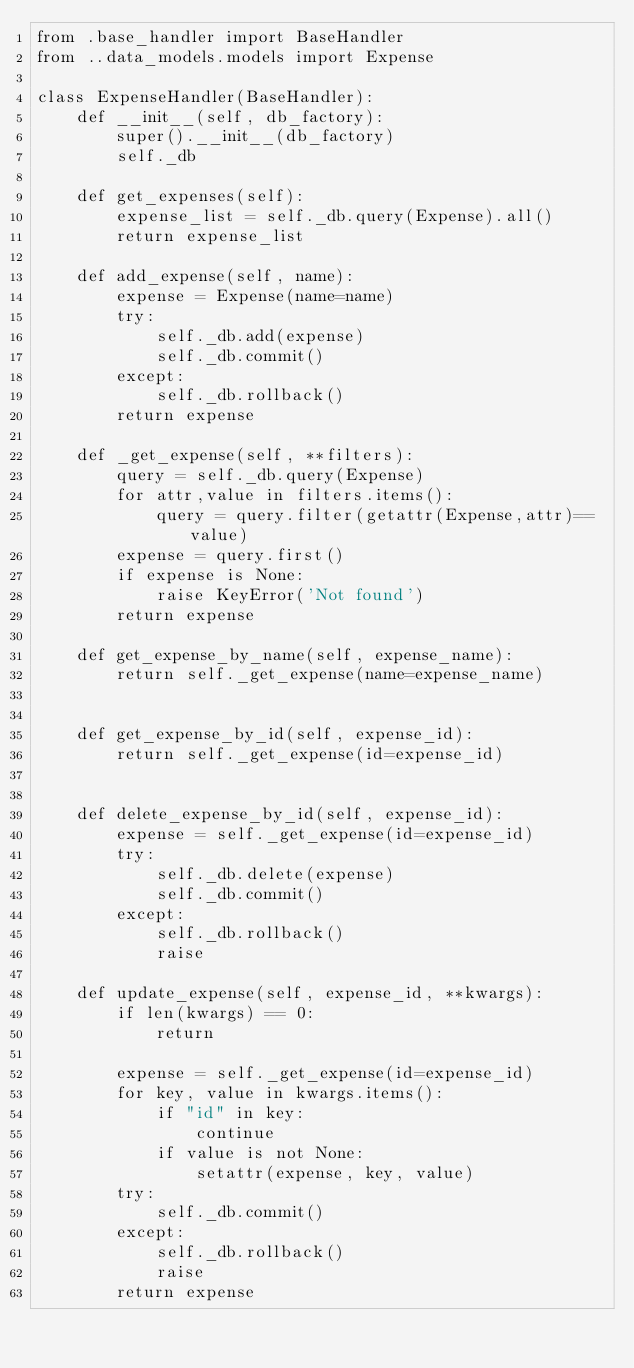Convert code to text. <code><loc_0><loc_0><loc_500><loc_500><_Python_>from .base_handler import BaseHandler
from ..data_models.models import Expense

class ExpenseHandler(BaseHandler):
	def __init__(self, db_factory):
		super().__init__(db_factory)
		self._db
	
	def get_expenses(self):
		expense_list = self._db.query(Expense).all()
		return expense_list

	def add_expense(self, name):
		expense = Expense(name=name)
		try:
			self._db.add(expense)
			self._db.commit()
		except:
			self._db.rollback()
		return expense

	def _get_expense(self, **filters):
		query = self._db.query(Expense)
		for attr,value in filters.items():
			query = query.filter(getattr(Expense,attr)==value)
		expense = query.first()
		if expense is None:
			raise KeyError('Not found')
		return expense

	def get_expense_by_name(self, expense_name):
		return self._get_expense(name=expense_name)


	def get_expense_by_id(self, expense_id):
		return self._get_expense(id=expense_id)


	def delete_expense_by_id(self, expense_id):
		expense = self._get_expense(id=expense_id)
		try:
			self._db.delete(expense)
			self._db.commit()
		except:
			self._db.rollback()
			raise

	def update_expense(self, expense_id, **kwargs):
		if len(kwargs) == 0:
			return

		expense = self._get_expense(id=expense_id)
		for key, value in kwargs.items():
			if "id" in key:
				continue
			if value is not None:
				setattr(expense, key, value)
		try:
			self._db.commit()
		except:
			self._db.rollback()
			raise
		return expense



</code> 